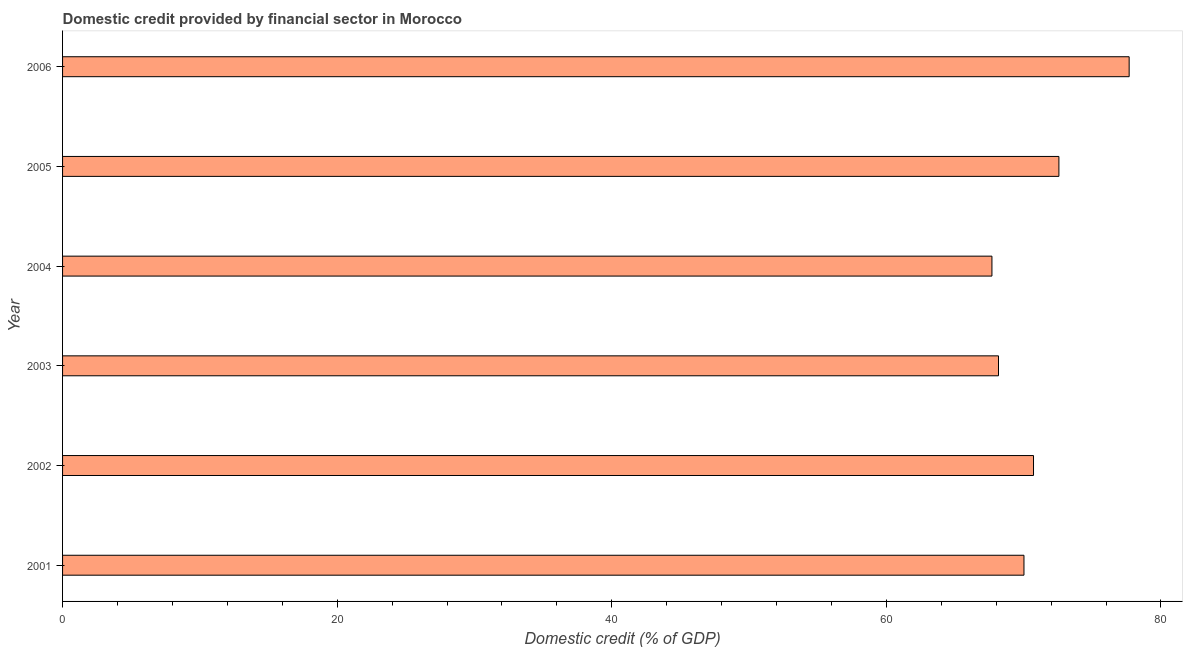Does the graph contain any zero values?
Offer a terse response. No. Does the graph contain grids?
Provide a succinct answer. No. What is the title of the graph?
Your answer should be compact. Domestic credit provided by financial sector in Morocco. What is the label or title of the X-axis?
Your answer should be very brief. Domestic credit (% of GDP). What is the domestic credit provided by financial sector in 2005?
Provide a short and direct response. 72.57. Across all years, what is the maximum domestic credit provided by financial sector?
Make the answer very short. 77.68. Across all years, what is the minimum domestic credit provided by financial sector?
Provide a short and direct response. 67.69. In which year was the domestic credit provided by financial sector minimum?
Keep it short and to the point. 2004. What is the sum of the domestic credit provided by financial sector?
Offer a very short reply. 426.85. What is the difference between the domestic credit provided by financial sector in 2001 and 2004?
Your answer should be compact. 2.33. What is the average domestic credit provided by financial sector per year?
Make the answer very short. 71.14. What is the median domestic credit provided by financial sector?
Offer a very short reply. 70.37. What is the ratio of the domestic credit provided by financial sector in 2005 to that in 2006?
Your response must be concise. 0.93. Is the difference between the domestic credit provided by financial sector in 2003 and 2006 greater than the difference between any two years?
Give a very brief answer. No. What is the difference between the highest and the second highest domestic credit provided by financial sector?
Make the answer very short. 5.12. What is the difference between the highest and the lowest domestic credit provided by financial sector?
Give a very brief answer. 9.99. Are all the bars in the graph horizontal?
Provide a short and direct response. Yes. Are the values on the major ticks of X-axis written in scientific E-notation?
Provide a succinct answer. No. What is the Domestic credit (% of GDP) of 2001?
Offer a terse response. 70.02. What is the Domestic credit (% of GDP) in 2002?
Ensure brevity in your answer.  70.72. What is the Domestic credit (% of GDP) of 2003?
Your response must be concise. 68.17. What is the Domestic credit (% of GDP) of 2004?
Keep it short and to the point. 67.69. What is the Domestic credit (% of GDP) in 2005?
Offer a very short reply. 72.57. What is the Domestic credit (% of GDP) in 2006?
Ensure brevity in your answer.  77.68. What is the difference between the Domestic credit (% of GDP) in 2001 and 2002?
Provide a short and direct response. -0.7. What is the difference between the Domestic credit (% of GDP) in 2001 and 2003?
Your answer should be very brief. 1.86. What is the difference between the Domestic credit (% of GDP) in 2001 and 2004?
Offer a very short reply. 2.33. What is the difference between the Domestic credit (% of GDP) in 2001 and 2005?
Make the answer very short. -2.55. What is the difference between the Domestic credit (% of GDP) in 2001 and 2006?
Your answer should be very brief. -7.66. What is the difference between the Domestic credit (% of GDP) in 2002 and 2003?
Offer a very short reply. 2.55. What is the difference between the Domestic credit (% of GDP) in 2002 and 2004?
Provide a short and direct response. 3.03. What is the difference between the Domestic credit (% of GDP) in 2002 and 2005?
Make the answer very short. -1.85. What is the difference between the Domestic credit (% of GDP) in 2002 and 2006?
Your answer should be very brief. -6.97. What is the difference between the Domestic credit (% of GDP) in 2003 and 2004?
Provide a short and direct response. 0.48. What is the difference between the Domestic credit (% of GDP) in 2003 and 2005?
Offer a very short reply. -4.4. What is the difference between the Domestic credit (% of GDP) in 2003 and 2006?
Provide a succinct answer. -9.52. What is the difference between the Domestic credit (% of GDP) in 2004 and 2005?
Offer a very short reply. -4.88. What is the difference between the Domestic credit (% of GDP) in 2004 and 2006?
Offer a terse response. -9.99. What is the difference between the Domestic credit (% of GDP) in 2005 and 2006?
Your response must be concise. -5.12. What is the ratio of the Domestic credit (% of GDP) in 2001 to that in 2002?
Give a very brief answer. 0.99. What is the ratio of the Domestic credit (% of GDP) in 2001 to that in 2004?
Provide a short and direct response. 1.03. What is the ratio of the Domestic credit (% of GDP) in 2001 to that in 2006?
Make the answer very short. 0.9. What is the ratio of the Domestic credit (% of GDP) in 2002 to that in 2004?
Offer a very short reply. 1.04. What is the ratio of the Domestic credit (% of GDP) in 2002 to that in 2006?
Keep it short and to the point. 0.91. What is the ratio of the Domestic credit (% of GDP) in 2003 to that in 2005?
Offer a terse response. 0.94. What is the ratio of the Domestic credit (% of GDP) in 2003 to that in 2006?
Your answer should be very brief. 0.88. What is the ratio of the Domestic credit (% of GDP) in 2004 to that in 2005?
Your answer should be compact. 0.93. What is the ratio of the Domestic credit (% of GDP) in 2004 to that in 2006?
Offer a terse response. 0.87. What is the ratio of the Domestic credit (% of GDP) in 2005 to that in 2006?
Your answer should be very brief. 0.93. 